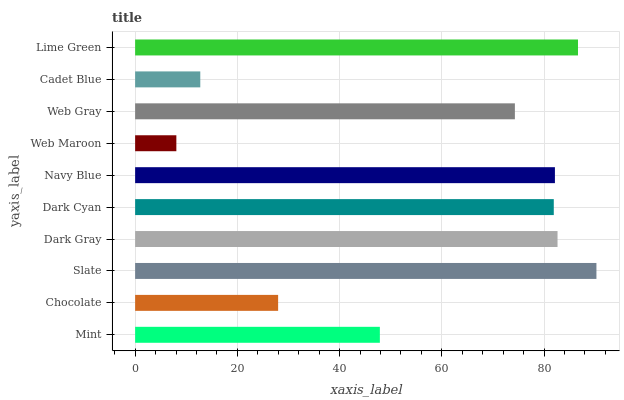Is Web Maroon the minimum?
Answer yes or no. Yes. Is Slate the maximum?
Answer yes or no. Yes. Is Chocolate the minimum?
Answer yes or no. No. Is Chocolate the maximum?
Answer yes or no. No. Is Mint greater than Chocolate?
Answer yes or no. Yes. Is Chocolate less than Mint?
Answer yes or no. Yes. Is Chocolate greater than Mint?
Answer yes or no. No. Is Mint less than Chocolate?
Answer yes or no. No. Is Dark Cyan the high median?
Answer yes or no. Yes. Is Web Gray the low median?
Answer yes or no. Yes. Is Slate the high median?
Answer yes or no. No. Is Chocolate the low median?
Answer yes or no. No. 